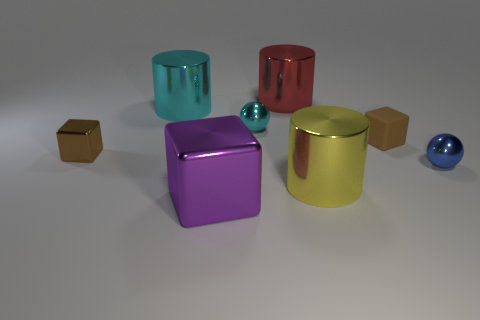Add 1 small blue things. How many objects exist? 9 Subtract all spheres. How many objects are left? 6 Add 4 cyan metallic objects. How many cyan metallic objects are left? 6 Add 5 yellow rubber cylinders. How many yellow rubber cylinders exist? 5 Subtract 0 green cylinders. How many objects are left? 8 Subtract all big purple cylinders. Subtract all cyan metallic cylinders. How many objects are left? 7 